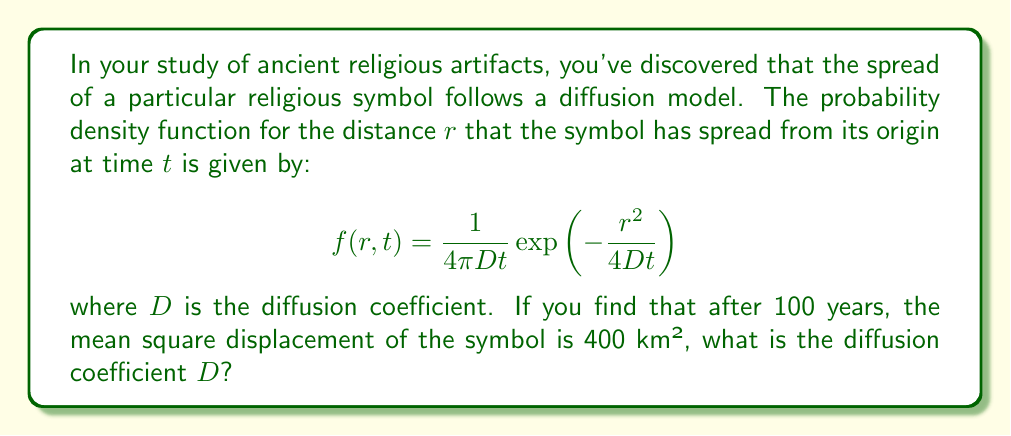Can you answer this question? To solve this problem, we'll follow these steps:

1) In a diffusion model, the mean square displacement $\langle r^2 \rangle$ is related to the diffusion coefficient $D$ and time $t$ by the equation:

   $$\langle r^2 \rangle = 4Dt$$

2) We're given that after 100 years (t = 100), the mean square displacement is 400 km². Let's substitute these values:

   $$400 = 4D(100)$$

3) Now we can solve for $D$:

   $$400 = 400D$$
   
   $$D = \frac{400}{400} = 1$$

4) Therefore, the diffusion coefficient $D$ is 1 km²/year.

This coefficient quantifies how quickly the religious symbol spread through the ancient culture, providing valuable insight into the rate of cultural diffusion in your historical research.
Answer: $D = 1$ km²/year 